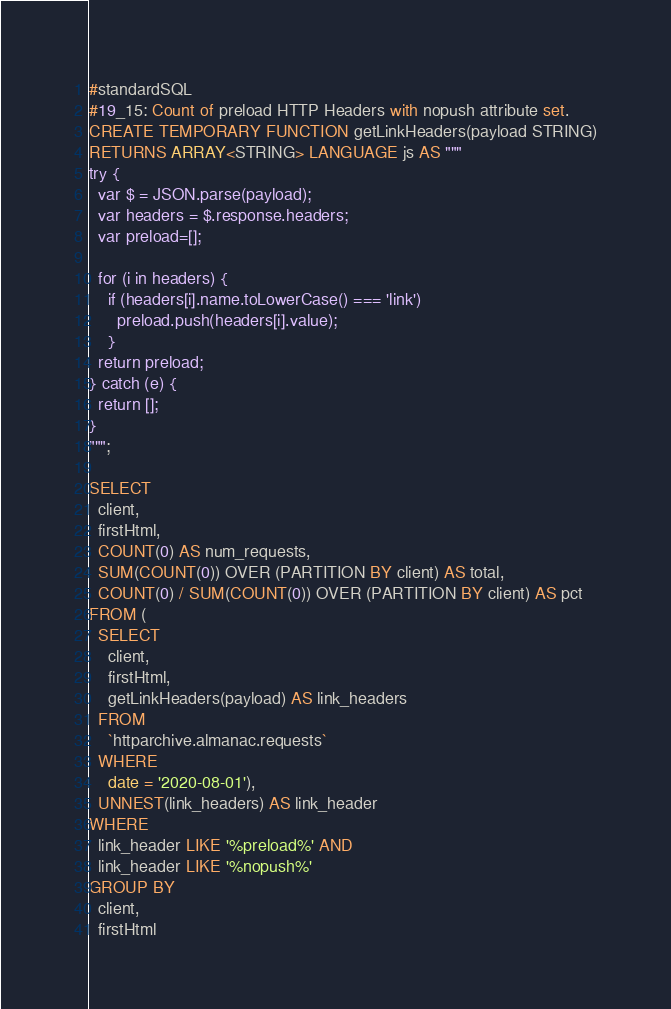Convert code to text. <code><loc_0><loc_0><loc_500><loc_500><_SQL_>#standardSQL
#19_15: Count of preload HTTP Headers with nopush attribute set.
CREATE TEMPORARY FUNCTION getLinkHeaders(payload STRING)
RETURNS ARRAY<STRING> LANGUAGE js AS """
try {
  var $ = JSON.parse(payload);
  var headers = $.response.headers;
  var preload=[];

  for (i in headers) {
    if (headers[i].name.toLowerCase() === 'link')
      preload.push(headers[i].value);
    }
  return preload;
} catch (e) {
  return [];
}
""";

SELECT
  client,
  firstHtml,
  COUNT(0) AS num_requests,
  SUM(COUNT(0)) OVER (PARTITION BY client) AS total,
  COUNT(0) / SUM(COUNT(0)) OVER (PARTITION BY client) AS pct
FROM (
  SELECT
    client,
    firstHtml,
    getLinkHeaders(payload) AS link_headers
  FROM
    `httparchive.almanac.requests`
  WHERE
    date = '2020-08-01'),
  UNNEST(link_headers) AS link_header
WHERE
  link_header LIKE '%preload%' AND
  link_header LIKE '%nopush%'
GROUP BY
  client,
  firstHtml</code> 